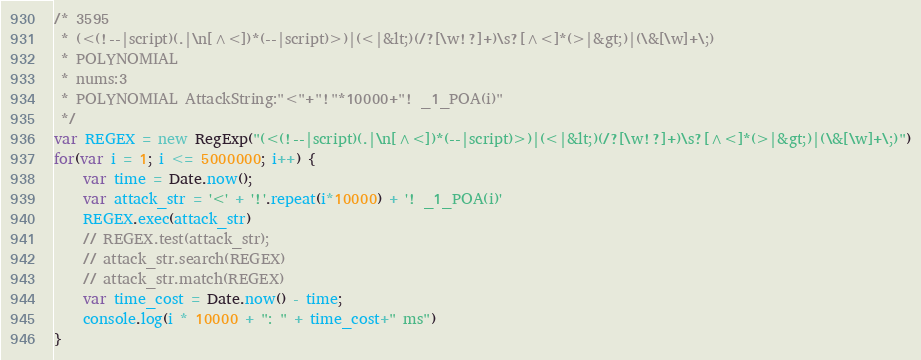<code> <loc_0><loc_0><loc_500><loc_500><_JavaScript_>/* 3595
 * (<(!--|script)(.|\n[^<])*(--|script)>)|(<|&lt;)(/?[\w!?]+)\s?[^<]*(>|&gt;)|(\&[\w]+\;)
 * POLYNOMIAL
 * nums:3
 * POLYNOMIAL AttackString:"<"+"!"*10000+"! _1_POA(i)"
 */
var REGEX = new RegExp("(<(!--|script)(.|\n[^<])*(--|script)>)|(<|&lt;)(/?[\w!?]+)\s?[^<]*(>|&gt;)|(\&[\w]+\;)")
for(var i = 1; i <= 5000000; i++) {
    var time = Date.now();
    var attack_str = '<' + '!'.repeat(i*10000) + '! _1_POA(i)'
    REGEX.exec(attack_str)
    // REGEX.test(attack_str);
    // attack_str.search(REGEX)
    // attack_str.match(REGEX)
    var time_cost = Date.now() - time;
    console.log(i * 10000 + ": " + time_cost+" ms")
}</code> 